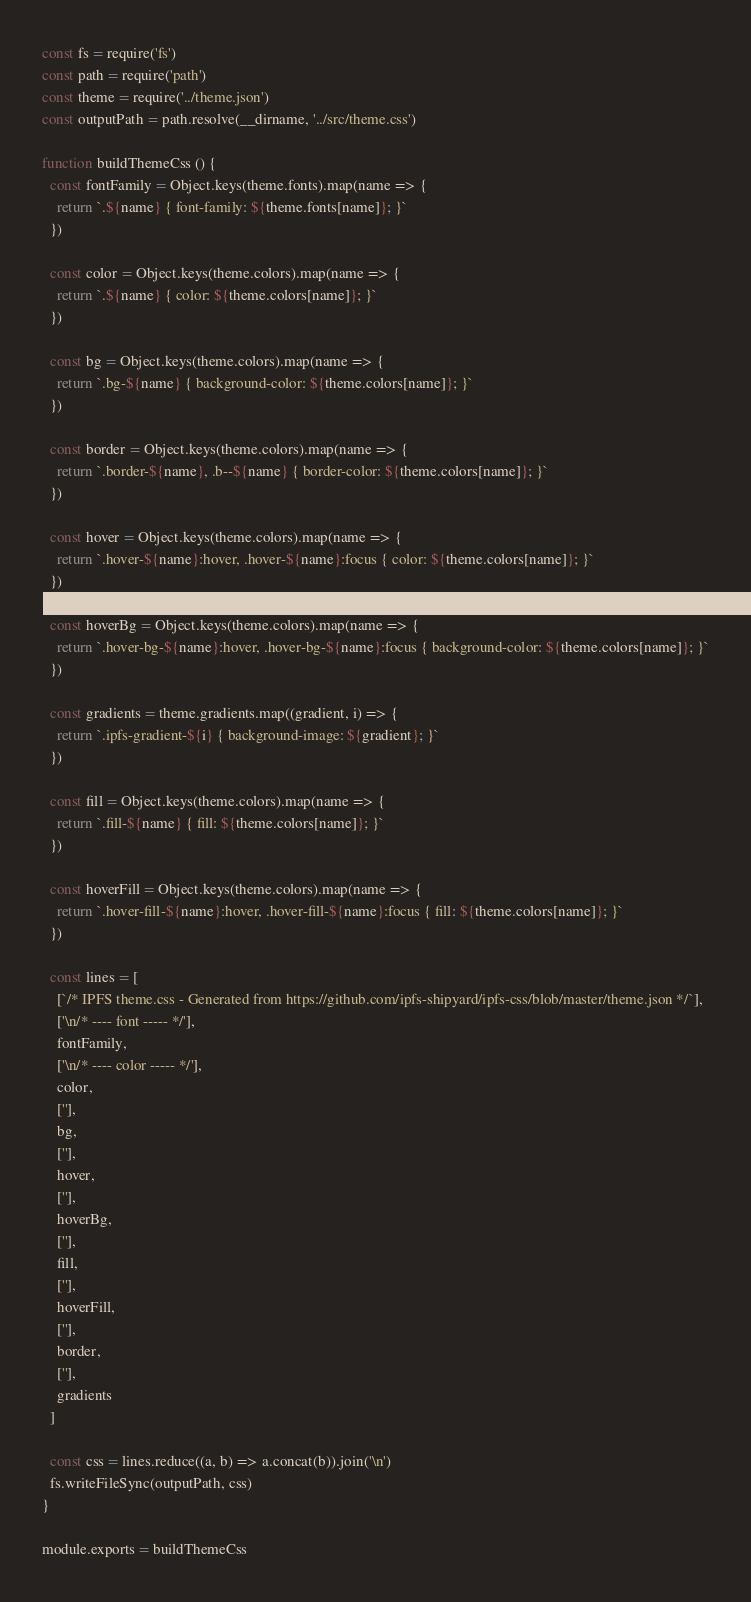<code> <loc_0><loc_0><loc_500><loc_500><_JavaScript_>const fs = require('fs')
const path = require('path')
const theme = require('../theme.json')
const outputPath = path.resolve(__dirname, '../src/theme.css')

function buildThemeCss () {
  const fontFamily = Object.keys(theme.fonts).map(name => {
    return `.${name} { font-family: ${theme.fonts[name]}; }`
  })

  const color = Object.keys(theme.colors).map(name => {
    return `.${name} { color: ${theme.colors[name]}; }`
  })

  const bg = Object.keys(theme.colors).map(name => {
    return `.bg-${name} { background-color: ${theme.colors[name]}; }`
  })

  const border = Object.keys(theme.colors).map(name => {
    return `.border-${name}, .b--${name} { border-color: ${theme.colors[name]}; }`
  })

  const hover = Object.keys(theme.colors).map(name => {
    return `.hover-${name}:hover, .hover-${name}:focus { color: ${theme.colors[name]}; }`
  })

  const hoverBg = Object.keys(theme.colors).map(name => {
    return `.hover-bg-${name}:hover, .hover-bg-${name}:focus { background-color: ${theme.colors[name]}; }`
  })

  const gradients = theme.gradients.map((gradient, i) => {
    return `.ipfs-gradient-${i} { background-image: ${gradient}; }`
  })

  const fill = Object.keys(theme.colors).map(name => {
    return `.fill-${name} { fill: ${theme.colors[name]}; }`
  })

  const hoverFill = Object.keys(theme.colors).map(name => {
    return `.hover-fill-${name}:hover, .hover-fill-${name}:focus { fill: ${theme.colors[name]}; }`
  })

  const lines = [
    [`/* IPFS theme.css - Generated from https://github.com/ipfs-shipyard/ipfs-css/blob/master/theme.json */`],
    ['\n/* ---- font ----- */'],
    fontFamily,
    ['\n/* ---- color ----- */'],
    color,
    [''],
    bg,
    [''],
    hover,
    [''],
    hoverBg,
    [''],
    fill,
    [''],
    hoverFill,
    [''],
    border,
    [''],
    gradients
  ]

  const css = lines.reduce((a, b) => a.concat(b)).join('\n')
  fs.writeFileSync(outputPath, css)
}

module.exports = buildThemeCss
</code> 